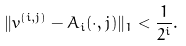Convert formula to latex. <formula><loc_0><loc_0><loc_500><loc_500>\| v ^ { ( i , j ) } - A _ { i } ( \cdot , j ) \| _ { 1 } < \frac { 1 } { 2 ^ { i } } .</formula> 